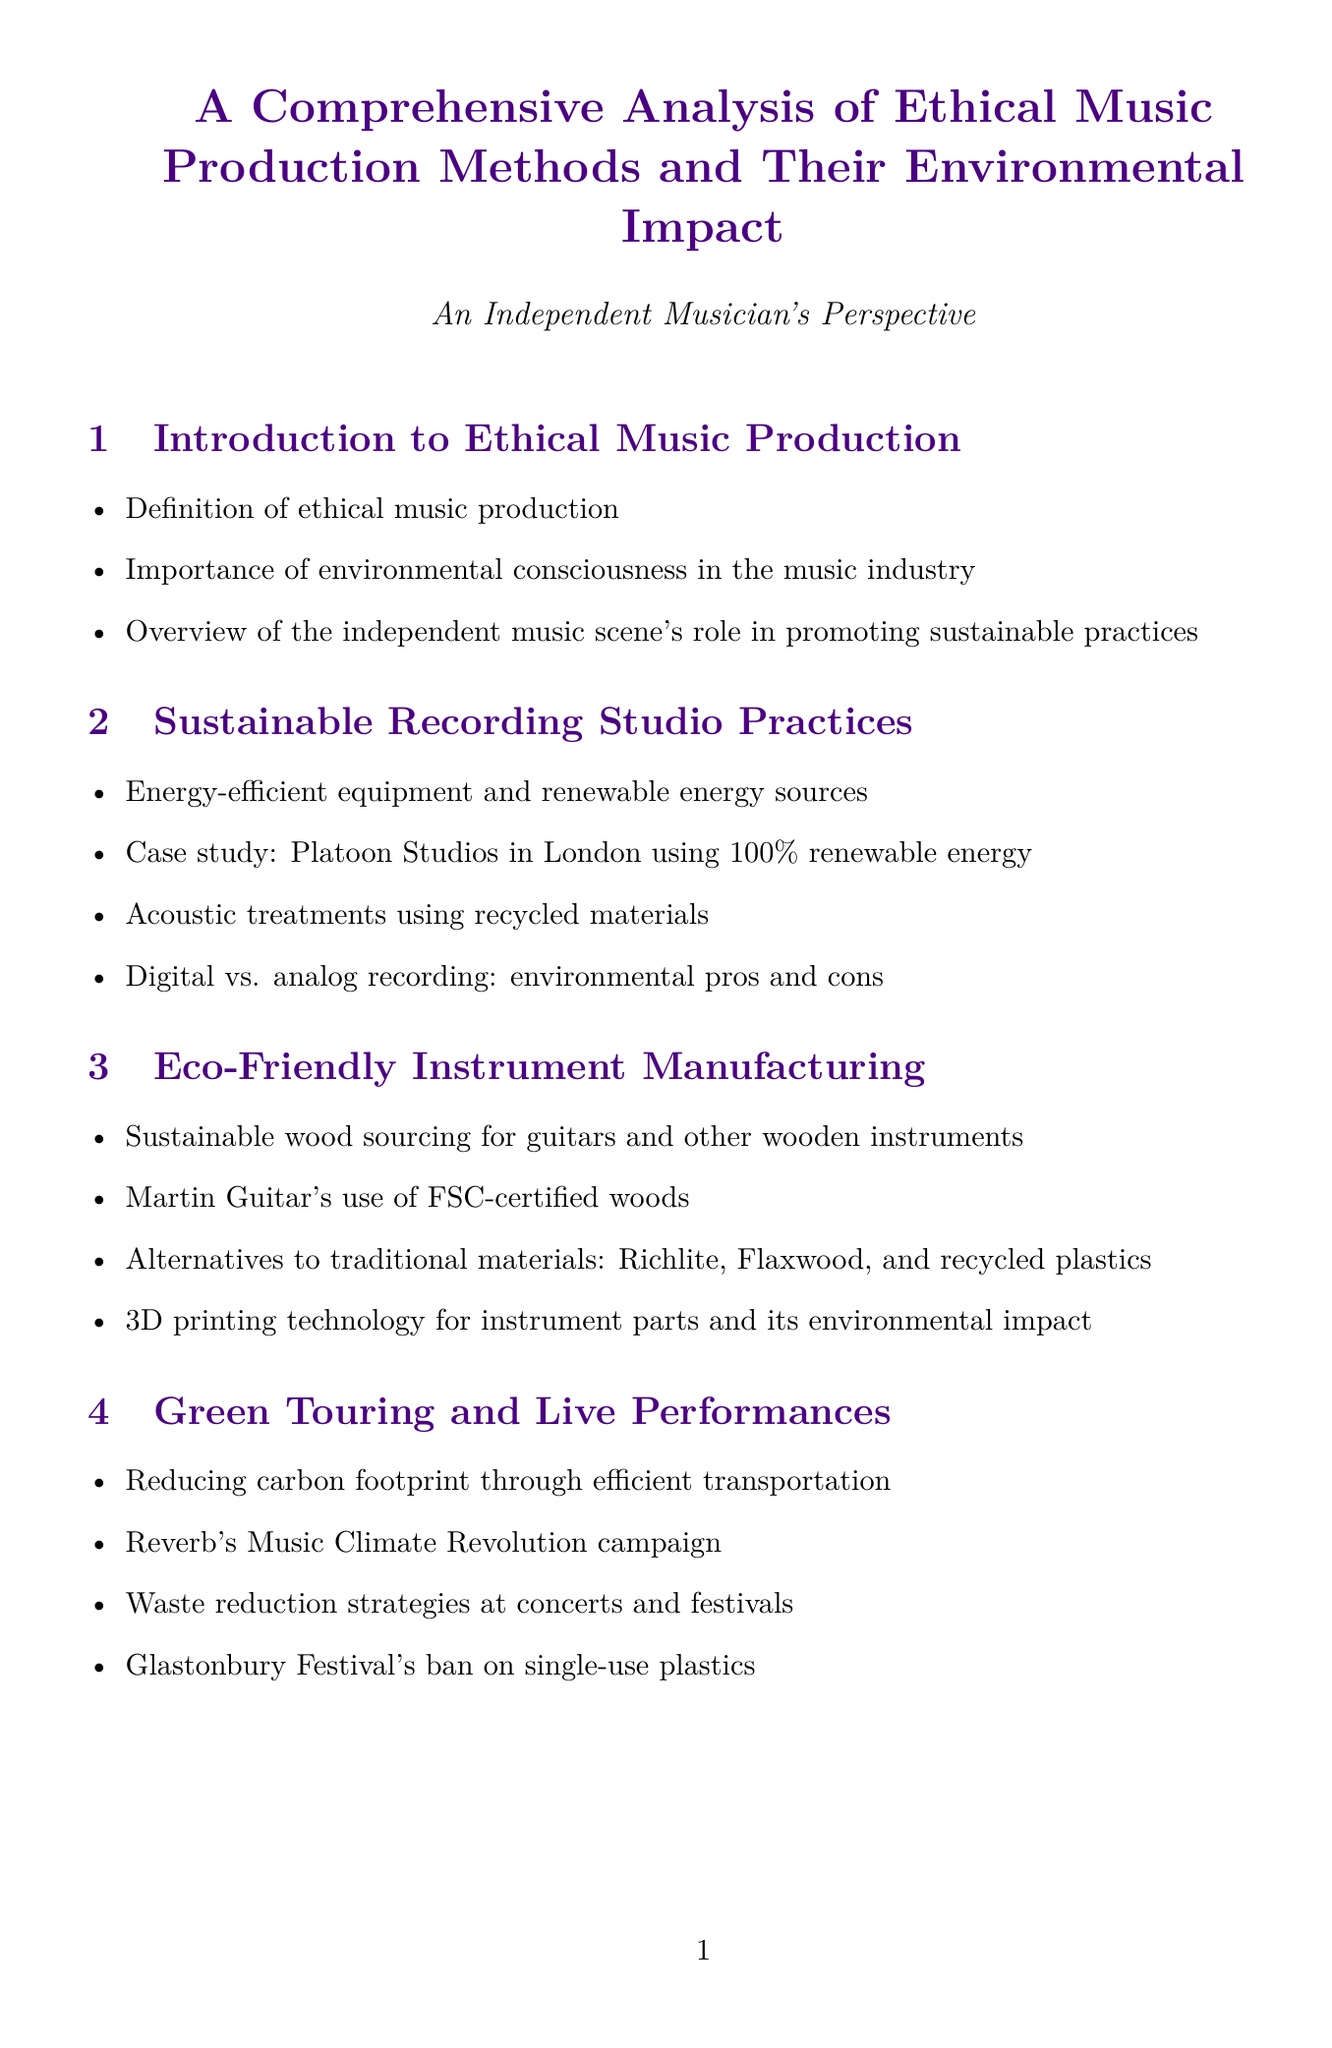What is ethical music production? Ethical music production is defined in the Introduction section of the document.
Answer: Definition of ethical music production Which studio is mentioned as using 100% renewable energy? The document highlights a case study in the Sustainable Recording Studio Practices section.
Answer: Platoon Studios What materials are used for eco-friendly instruments? The Eco-Friendly Instrument Manufacturing section discusses alternatives to traditional materials.
Answer: Richlite, Flaxwood, and recycled plastics What is one waste reduction strategy at concerts? This information is included in the Green Touring and Live Performances section.
Answer: Waste reduction strategies Which organization promotes the idea of fair artist compensation? The Ethical Music Distribution and Streaming section mentions a technology that supports this idea.
Answer: Blockchain technology What aesthetic does lo-fi music respond to? The DIY and Lo-Fi Production Techniques section addresses this point.
Answer: Over-consumption in music What is one feature of online collaboration tools for sustainable music creation? The Collaborative Platforms for Sustainable Music Creation section explains their benefits.
Answer: Reducing the need for travel What type of packaging did Radiohead use for their album 'In Rainbows'? The document describes this in the Ethical Merchandising and Packaging section.
Answer: Biodegradable CD packaging What initiative is mentioned for promoting environmental consciousness? The Education and Awareness in the Music Community section includes this detail.
Answer: Jack Johnson's All At Once social action network 